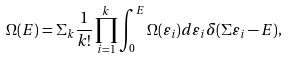<formula> <loc_0><loc_0><loc_500><loc_500>\Omega ( E ) = \Sigma _ { k } \frac { 1 } { k ! } \prod _ { i = 1 } ^ { k } \int _ { 0 } ^ { E } \Omega ( \varepsilon _ { i } ) d \varepsilon _ { i } \delta ( \Sigma { \varepsilon _ { i } } - E ) ,</formula> 